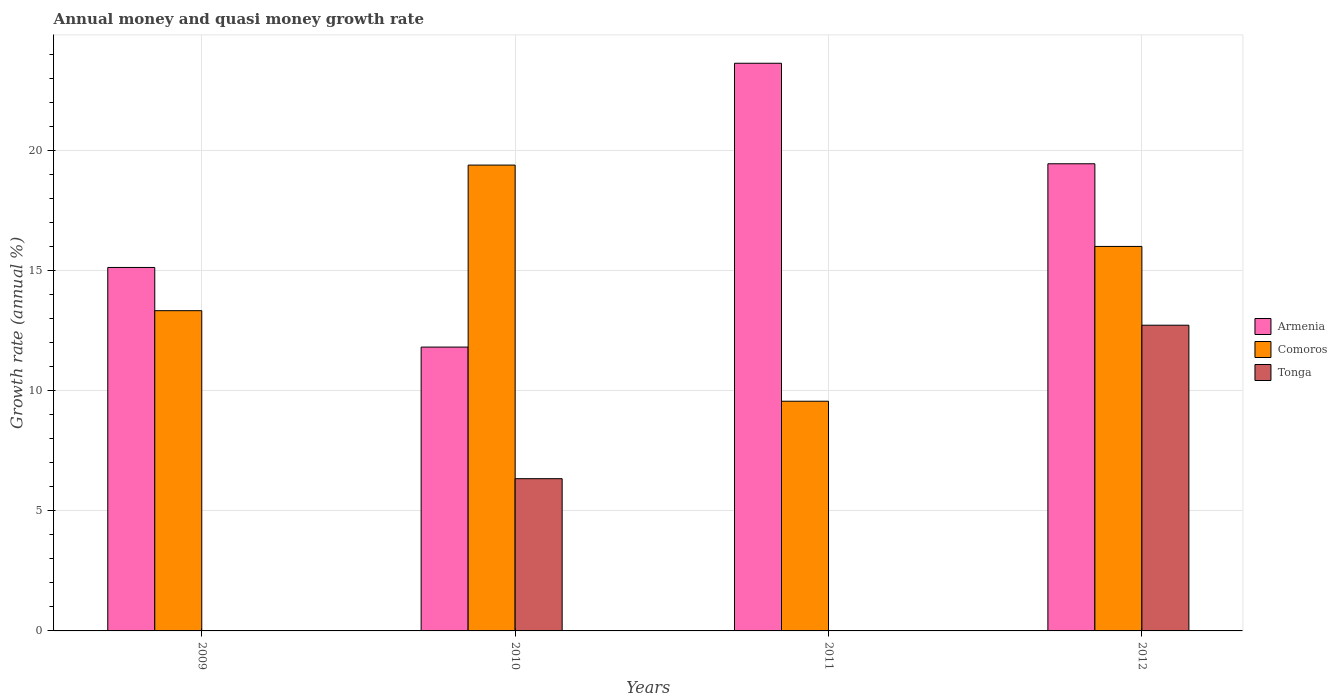How many different coloured bars are there?
Give a very brief answer. 3. What is the label of the 3rd group of bars from the left?
Make the answer very short. 2011. What is the growth rate in Tonga in 2010?
Your answer should be very brief. 6.34. Across all years, what is the maximum growth rate in Comoros?
Ensure brevity in your answer.  19.41. Across all years, what is the minimum growth rate in Comoros?
Your answer should be very brief. 9.57. In which year was the growth rate in Tonga maximum?
Make the answer very short. 2012. What is the total growth rate in Comoros in the graph?
Provide a succinct answer. 58.35. What is the difference between the growth rate in Comoros in 2009 and that in 2011?
Your answer should be very brief. 3.77. What is the difference between the growth rate in Comoros in 2009 and the growth rate in Armenia in 2012?
Your answer should be very brief. -6.12. What is the average growth rate in Armenia per year?
Make the answer very short. 17.52. In the year 2012, what is the difference between the growth rate in Tonga and growth rate in Armenia?
Your answer should be compact. -6.73. In how many years, is the growth rate in Comoros greater than 17 %?
Your answer should be compact. 1. What is the ratio of the growth rate in Comoros in 2010 to that in 2011?
Offer a very short reply. 2.03. Is the growth rate in Comoros in 2009 less than that in 2012?
Provide a succinct answer. Yes. What is the difference between the highest and the second highest growth rate in Armenia?
Keep it short and to the point. 4.19. What is the difference between the highest and the lowest growth rate in Armenia?
Keep it short and to the point. 11.83. Are all the bars in the graph horizontal?
Your response must be concise. No. How many years are there in the graph?
Your answer should be compact. 4. Are the values on the major ticks of Y-axis written in scientific E-notation?
Your answer should be compact. No. Does the graph contain any zero values?
Give a very brief answer. Yes. Where does the legend appear in the graph?
Keep it short and to the point. Center right. How many legend labels are there?
Ensure brevity in your answer.  3. How are the legend labels stacked?
Provide a succinct answer. Vertical. What is the title of the graph?
Offer a terse response. Annual money and quasi money growth rate. What is the label or title of the X-axis?
Ensure brevity in your answer.  Years. What is the label or title of the Y-axis?
Give a very brief answer. Growth rate (annual %). What is the Growth rate (annual %) of Armenia in 2009?
Offer a very short reply. 15.15. What is the Growth rate (annual %) in Comoros in 2009?
Offer a terse response. 13.34. What is the Growth rate (annual %) of Tonga in 2009?
Provide a short and direct response. 0. What is the Growth rate (annual %) in Armenia in 2010?
Give a very brief answer. 11.83. What is the Growth rate (annual %) in Comoros in 2010?
Provide a succinct answer. 19.41. What is the Growth rate (annual %) in Tonga in 2010?
Ensure brevity in your answer.  6.34. What is the Growth rate (annual %) in Armenia in 2011?
Provide a short and direct response. 23.66. What is the Growth rate (annual %) in Comoros in 2011?
Your answer should be compact. 9.57. What is the Growth rate (annual %) in Armenia in 2012?
Keep it short and to the point. 19.47. What is the Growth rate (annual %) of Comoros in 2012?
Ensure brevity in your answer.  16.02. What is the Growth rate (annual %) in Tonga in 2012?
Provide a succinct answer. 12.74. Across all years, what is the maximum Growth rate (annual %) in Armenia?
Your response must be concise. 23.66. Across all years, what is the maximum Growth rate (annual %) in Comoros?
Make the answer very short. 19.41. Across all years, what is the maximum Growth rate (annual %) in Tonga?
Provide a short and direct response. 12.74. Across all years, what is the minimum Growth rate (annual %) of Armenia?
Provide a succinct answer. 11.83. Across all years, what is the minimum Growth rate (annual %) of Comoros?
Your answer should be compact. 9.57. Across all years, what is the minimum Growth rate (annual %) of Tonga?
Keep it short and to the point. 0. What is the total Growth rate (annual %) of Armenia in the graph?
Offer a terse response. 70.1. What is the total Growth rate (annual %) in Comoros in the graph?
Make the answer very short. 58.35. What is the total Growth rate (annual %) of Tonga in the graph?
Give a very brief answer. 19.08. What is the difference between the Growth rate (annual %) in Armenia in 2009 and that in 2010?
Provide a short and direct response. 3.32. What is the difference between the Growth rate (annual %) in Comoros in 2009 and that in 2010?
Keep it short and to the point. -6.07. What is the difference between the Growth rate (annual %) in Armenia in 2009 and that in 2011?
Ensure brevity in your answer.  -8.51. What is the difference between the Growth rate (annual %) of Comoros in 2009 and that in 2011?
Make the answer very short. 3.77. What is the difference between the Growth rate (annual %) of Armenia in 2009 and that in 2012?
Make the answer very short. -4.32. What is the difference between the Growth rate (annual %) in Comoros in 2009 and that in 2012?
Give a very brief answer. -2.68. What is the difference between the Growth rate (annual %) in Armenia in 2010 and that in 2011?
Your answer should be compact. -11.83. What is the difference between the Growth rate (annual %) of Comoros in 2010 and that in 2011?
Keep it short and to the point. 9.84. What is the difference between the Growth rate (annual %) in Armenia in 2010 and that in 2012?
Your answer should be compact. -7.64. What is the difference between the Growth rate (annual %) of Comoros in 2010 and that in 2012?
Your answer should be very brief. 3.39. What is the difference between the Growth rate (annual %) of Tonga in 2010 and that in 2012?
Ensure brevity in your answer.  -6.4. What is the difference between the Growth rate (annual %) of Armenia in 2011 and that in 2012?
Provide a succinct answer. 4.19. What is the difference between the Growth rate (annual %) of Comoros in 2011 and that in 2012?
Provide a succinct answer. -6.45. What is the difference between the Growth rate (annual %) of Armenia in 2009 and the Growth rate (annual %) of Comoros in 2010?
Keep it short and to the point. -4.27. What is the difference between the Growth rate (annual %) of Armenia in 2009 and the Growth rate (annual %) of Tonga in 2010?
Keep it short and to the point. 8.8. What is the difference between the Growth rate (annual %) in Comoros in 2009 and the Growth rate (annual %) in Tonga in 2010?
Keep it short and to the point. 7. What is the difference between the Growth rate (annual %) in Armenia in 2009 and the Growth rate (annual %) in Comoros in 2011?
Your answer should be very brief. 5.57. What is the difference between the Growth rate (annual %) of Armenia in 2009 and the Growth rate (annual %) of Comoros in 2012?
Your answer should be compact. -0.88. What is the difference between the Growth rate (annual %) in Armenia in 2009 and the Growth rate (annual %) in Tonga in 2012?
Give a very brief answer. 2.41. What is the difference between the Growth rate (annual %) in Comoros in 2009 and the Growth rate (annual %) in Tonga in 2012?
Offer a terse response. 0.61. What is the difference between the Growth rate (annual %) of Armenia in 2010 and the Growth rate (annual %) of Comoros in 2011?
Provide a short and direct response. 2.26. What is the difference between the Growth rate (annual %) in Armenia in 2010 and the Growth rate (annual %) in Comoros in 2012?
Offer a very short reply. -4.19. What is the difference between the Growth rate (annual %) of Armenia in 2010 and the Growth rate (annual %) of Tonga in 2012?
Your answer should be compact. -0.91. What is the difference between the Growth rate (annual %) of Comoros in 2010 and the Growth rate (annual %) of Tonga in 2012?
Provide a succinct answer. 6.67. What is the difference between the Growth rate (annual %) in Armenia in 2011 and the Growth rate (annual %) in Comoros in 2012?
Give a very brief answer. 7.63. What is the difference between the Growth rate (annual %) in Armenia in 2011 and the Growth rate (annual %) in Tonga in 2012?
Provide a succinct answer. 10.92. What is the difference between the Growth rate (annual %) in Comoros in 2011 and the Growth rate (annual %) in Tonga in 2012?
Keep it short and to the point. -3.17. What is the average Growth rate (annual %) in Armenia per year?
Make the answer very short. 17.52. What is the average Growth rate (annual %) of Comoros per year?
Offer a very short reply. 14.59. What is the average Growth rate (annual %) in Tonga per year?
Your answer should be very brief. 4.77. In the year 2009, what is the difference between the Growth rate (annual %) of Armenia and Growth rate (annual %) of Comoros?
Make the answer very short. 1.8. In the year 2010, what is the difference between the Growth rate (annual %) in Armenia and Growth rate (annual %) in Comoros?
Give a very brief answer. -7.58. In the year 2010, what is the difference between the Growth rate (annual %) of Armenia and Growth rate (annual %) of Tonga?
Give a very brief answer. 5.48. In the year 2010, what is the difference between the Growth rate (annual %) of Comoros and Growth rate (annual %) of Tonga?
Your answer should be very brief. 13.07. In the year 2011, what is the difference between the Growth rate (annual %) of Armenia and Growth rate (annual %) of Comoros?
Your answer should be compact. 14.08. In the year 2012, what is the difference between the Growth rate (annual %) in Armenia and Growth rate (annual %) in Comoros?
Provide a short and direct response. 3.44. In the year 2012, what is the difference between the Growth rate (annual %) in Armenia and Growth rate (annual %) in Tonga?
Keep it short and to the point. 6.73. In the year 2012, what is the difference between the Growth rate (annual %) in Comoros and Growth rate (annual %) in Tonga?
Your answer should be compact. 3.28. What is the ratio of the Growth rate (annual %) in Armenia in 2009 to that in 2010?
Your answer should be compact. 1.28. What is the ratio of the Growth rate (annual %) of Comoros in 2009 to that in 2010?
Offer a very short reply. 0.69. What is the ratio of the Growth rate (annual %) in Armenia in 2009 to that in 2011?
Make the answer very short. 0.64. What is the ratio of the Growth rate (annual %) in Comoros in 2009 to that in 2011?
Give a very brief answer. 1.39. What is the ratio of the Growth rate (annual %) in Armenia in 2009 to that in 2012?
Ensure brevity in your answer.  0.78. What is the ratio of the Growth rate (annual %) in Comoros in 2009 to that in 2012?
Your response must be concise. 0.83. What is the ratio of the Growth rate (annual %) in Comoros in 2010 to that in 2011?
Your response must be concise. 2.03. What is the ratio of the Growth rate (annual %) in Armenia in 2010 to that in 2012?
Offer a terse response. 0.61. What is the ratio of the Growth rate (annual %) in Comoros in 2010 to that in 2012?
Your answer should be compact. 1.21. What is the ratio of the Growth rate (annual %) of Tonga in 2010 to that in 2012?
Your answer should be compact. 0.5. What is the ratio of the Growth rate (annual %) of Armenia in 2011 to that in 2012?
Keep it short and to the point. 1.22. What is the ratio of the Growth rate (annual %) in Comoros in 2011 to that in 2012?
Offer a very short reply. 0.6. What is the difference between the highest and the second highest Growth rate (annual %) in Armenia?
Your answer should be compact. 4.19. What is the difference between the highest and the second highest Growth rate (annual %) of Comoros?
Your answer should be very brief. 3.39. What is the difference between the highest and the lowest Growth rate (annual %) of Armenia?
Give a very brief answer. 11.83. What is the difference between the highest and the lowest Growth rate (annual %) of Comoros?
Give a very brief answer. 9.84. What is the difference between the highest and the lowest Growth rate (annual %) of Tonga?
Provide a short and direct response. 12.74. 